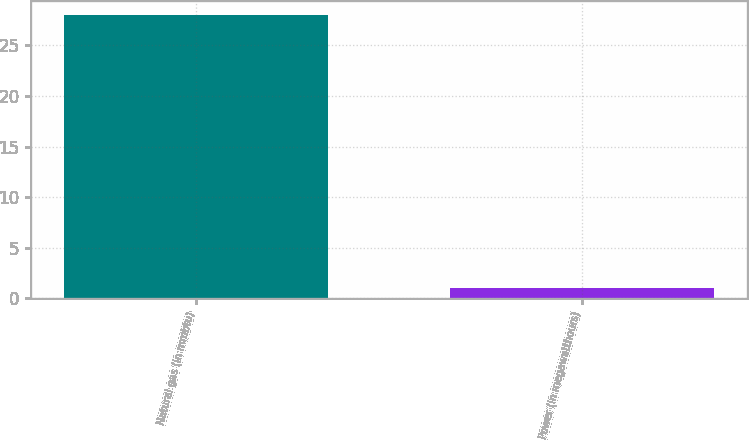<chart> <loc_0><loc_0><loc_500><loc_500><bar_chart><fcel>Natural gas (in mmbtu)<fcel>Power (in megawatthours)<nl><fcel>28<fcel>1<nl></chart> 